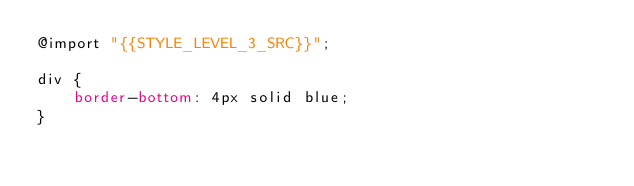<code> <loc_0><loc_0><loc_500><loc_500><_CSS_>@import "{{STYLE_LEVEL_3_SRC}}";

div {
	border-bottom: 4px solid blue;
}
</code> 